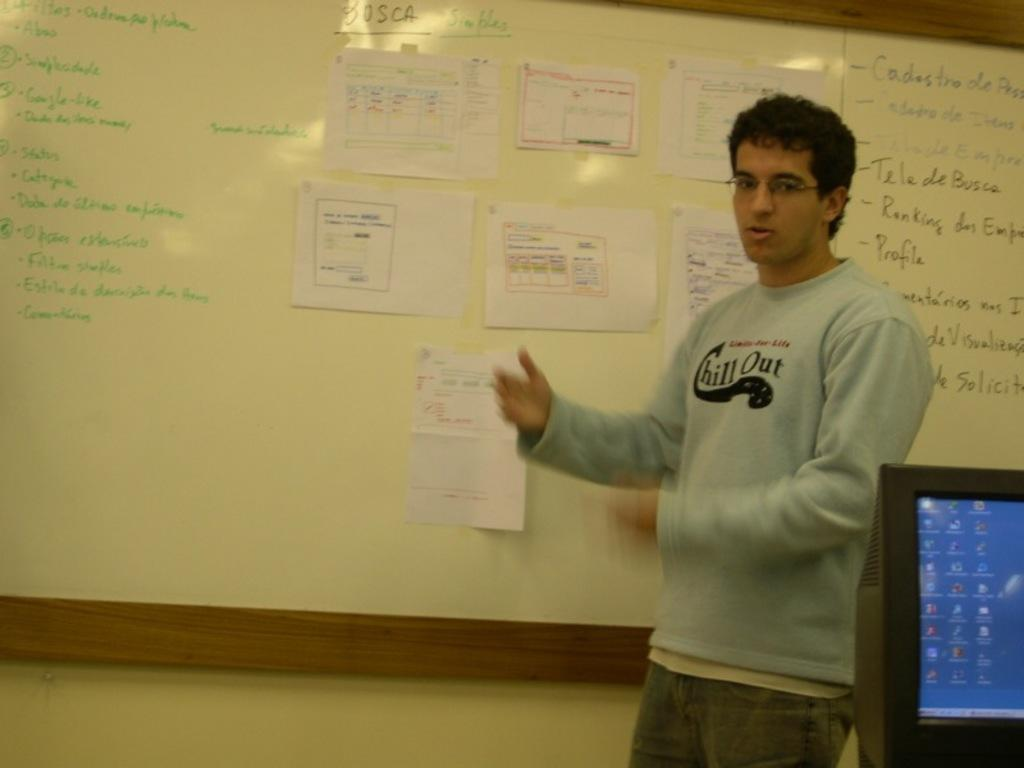<image>
Share a concise interpretation of the image provided. A man standing in front of a white board with a grey sweatshirt with the words chill out on it. 